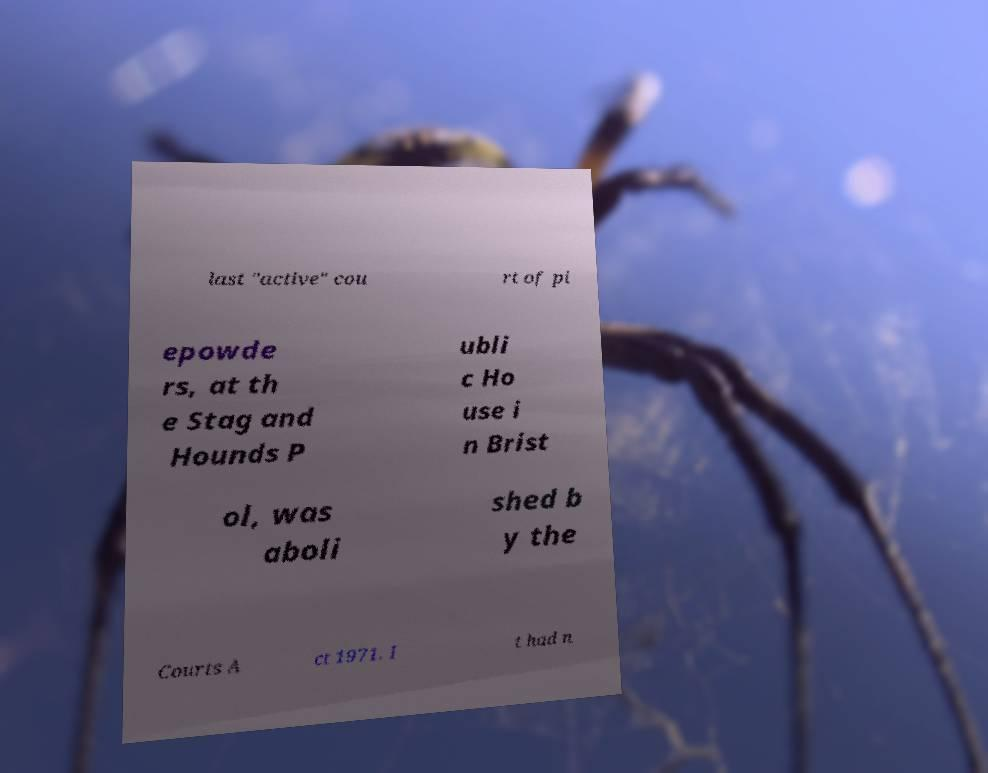What messages or text are displayed in this image? I need them in a readable, typed format. last "active" cou rt of pi epowde rs, at th e Stag and Hounds P ubli c Ho use i n Brist ol, was aboli shed b y the Courts A ct 1971. I t had n 